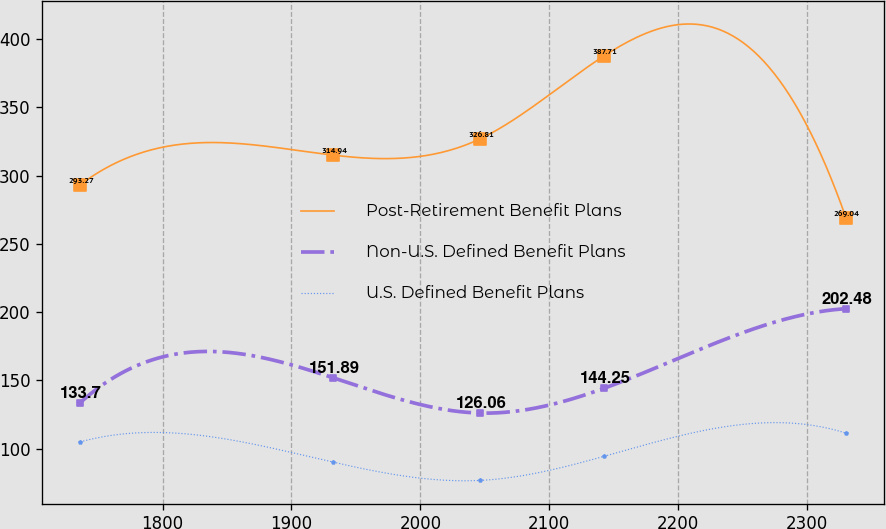Convert chart. <chart><loc_0><loc_0><loc_500><loc_500><line_chart><ecel><fcel>Post-Retirement Benefit Plans<fcel>Non-U.S. Defined Benefit Plans<fcel>U.S. Defined Benefit Plans<nl><fcel>1736.03<fcel>293.27<fcel>133.7<fcel>104.94<nl><fcel>1932.32<fcel>314.94<fcel>151.89<fcel>90.1<nl><fcel>2046.31<fcel>326.81<fcel>126.06<fcel>76.73<nl><fcel>2142.77<fcel>387.71<fcel>144.25<fcel>94.42<nl><fcel>2330.39<fcel>269.04<fcel>202.48<fcel>111.36<nl></chart> 